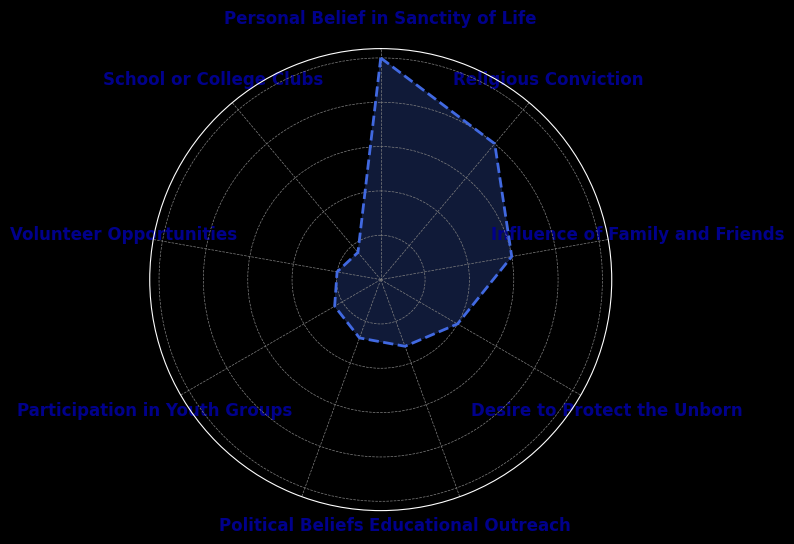What is the most common reason for youth involvement in the pro-life movement? The segment with the largest area on the rose chart represents the most common reason. The "Personal Belief in Sanctity of Life" segment has the largest area.
Answer: Personal Belief in Sanctity of Life Which reason is more influential, "Religious Conviction" or "Desire to Protect the Unborn"? By visually comparing the sizes of the segments for these reasons, the "Religious Conviction" segment is larger.
Answer: Religious Conviction What is the total percentage of youth involved due to "Educational Outreach" and "Political Beliefs"? Add the percentages for "Educational Outreach" (8%) and "Political Beliefs" (7%). 8% + 7% = 15%.
Answer: 15% How much greater is the percentage for "Influence of Family and Friends" compared to "Volunteer Opportunities"? Subtract the percentage for "Volunteer Opportunities" (5%) from "Influence of Family and Friends" (15%). 15% - 5% = 10%.
Answer: 10% What percentage is attributed to school-related activities ("School or College Clubs" and "Participation in Youth Groups")? Add the percentages for "School or College Clubs" (4%) and "Participation in Youth Groups" (6%). 4% + 6% = 10%.
Answer: 10% Which category has the smallest percentage, and what is it? The smallest segment corresponds to the "School or College Clubs" which has the smallest percentage.
Answer: School or College Clubs Is "Religious Conviction" a more common reason than "Influence of Family and Friends"? "Religious Conviction" has a percentage of 20%, whereas "Influence of Family and Friends" has 15%.
Answer: Yes What percentage of youth are involved due to reasons other than "Personal Belief in Sanctity of Life" and "Religious Conviction"? Subtract the combined percentage of "Personal Belief in Sanctity of Life" (25%) and "Religious Conviction" (20%) from 100%. 100% - 25% - 20% = 55%.
Answer: 55% Which category is responsible for a greater proportion of youth involvement, "Volunteer Opportunities" or "Participation in Youth Groups"? "Participation in Youth Groups" accounts for 6%, whereas "Volunteer Opportunities" accounts for 5%.
Answer: Participation in Youth Groups 